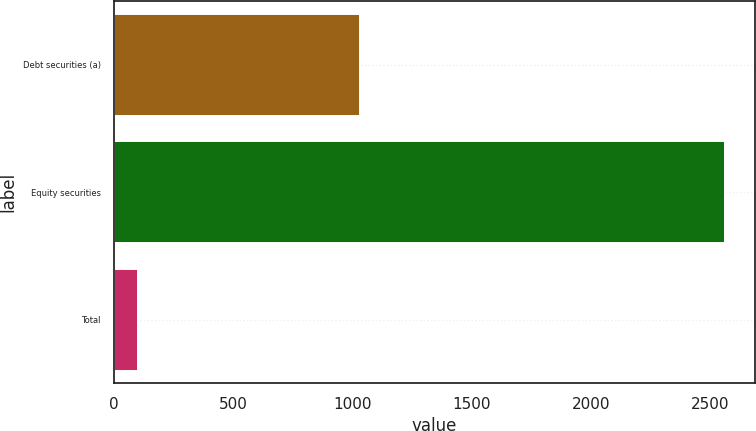Convert chart to OTSL. <chart><loc_0><loc_0><loc_500><loc_500><bar_chart><fcel>Debt securities (a)<fcel>Equity securities<fcel>Total<nl><fcel>1030<fcel>2560<fcel>100<nl></chart> 